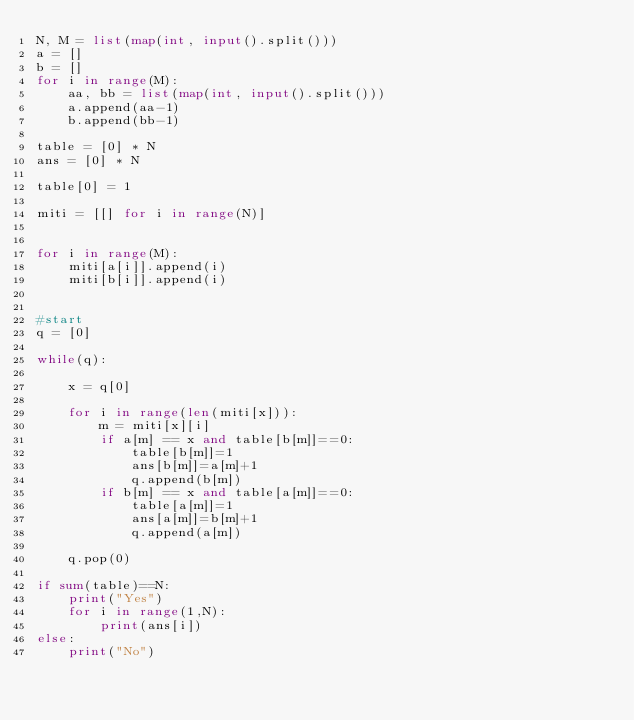<code> <loc_0><loc_0><loc_500><loc_500><_Python_>N, M = list(map(int, input().split()))
a = []
b = []
for i in range(M):
    aa, bb = list(map(int, input().split()))
    a.append(aa-1)
    b.append(bb-1)
    
table = [0] * N
ans = [0] * N

table[0] = 1

miti = [[] for i in range(N)]


for i in range(M):
    miti[a[i]].append(i)
    miti[b[i]].append(i)


#start
q = [0]

while(q):
    
    x = q[0]
    
    for i in range(len(miti[x])):
        m = miti[x][i]
        if a[m] == x and table[b[m]]==0:
            table[b[m]]=1
            ans[b[m]]=a[m]+1
            q.append(b[m])
        if b[m] == x and table[a[m]]==0:
            table[a[m]]=1
            ans[a[m]]=b[m]+1
            q.append(a[m])         
    
    q.pop(0)

if sum(table)==N:
    print("Yes")
    for i in range(1,N):
        print(ans[i])
else:
    print("No")
</code> 